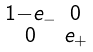<formula> <loc_0><loc_0><loc_500><loc_500>\begin{smallmatrix} 1 - e _ { - } & 0 \\ 0 & e _ { + } \end{smallmatrix}</formula> 